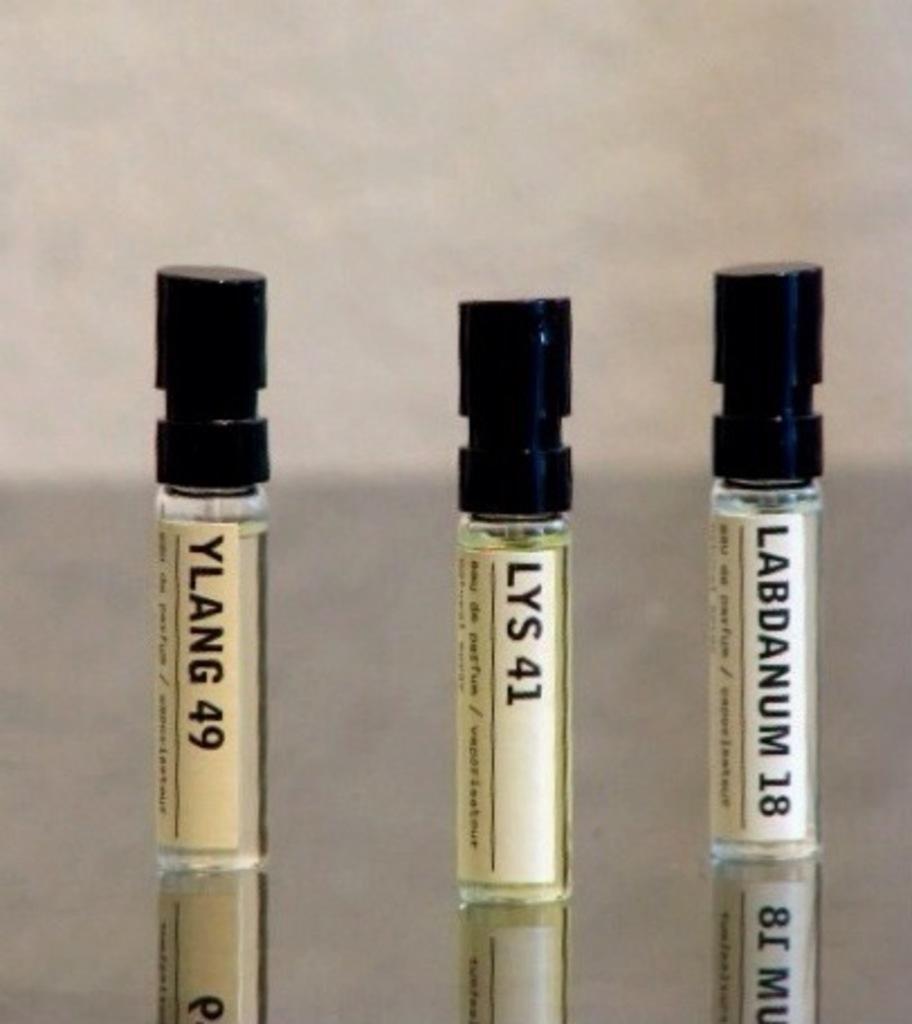What is in the middle vial?
Offer a terse response. Lys 41. 